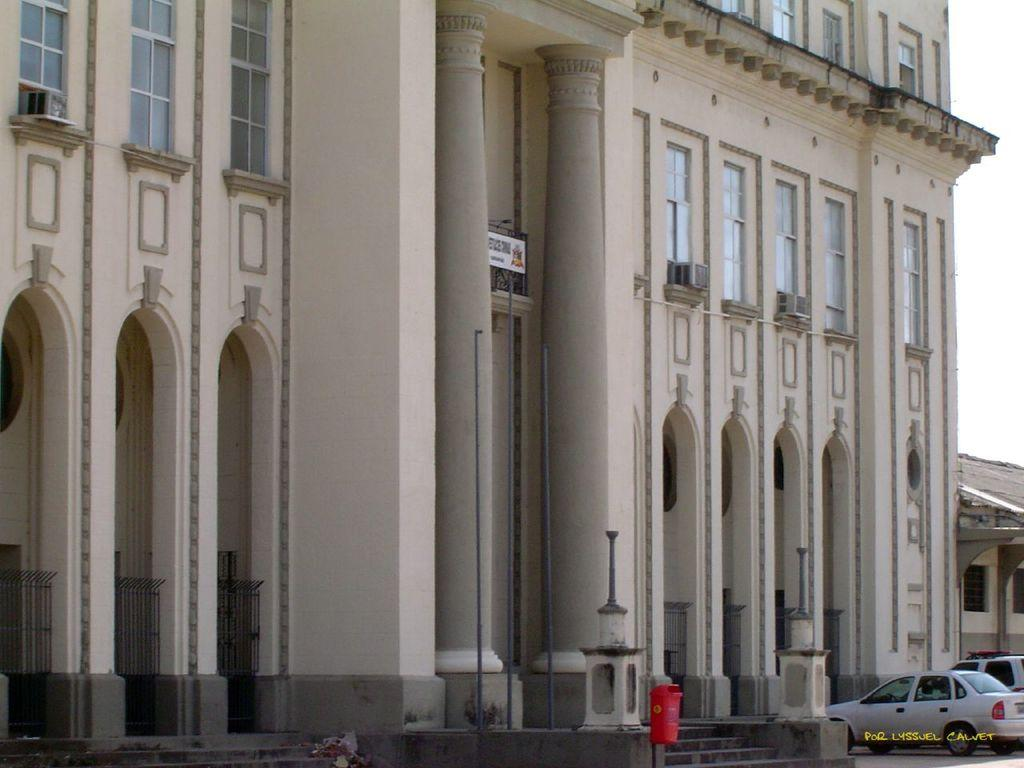What type of structure is present in the image? There is a building in the image. What can be seen at the bottom of the image? Cars and stairs are visible at the bottom of the image. What color is the object at the bottom of the image? There is a red color object at the bottom of the image. What is visible on the right side of the image? The sky is visible on the right side of the image. How many fingers can be seen on the building in the image? There are no fingers present on the building in the image. Are there any visible toes in the image? There are no visible toes in the image. 